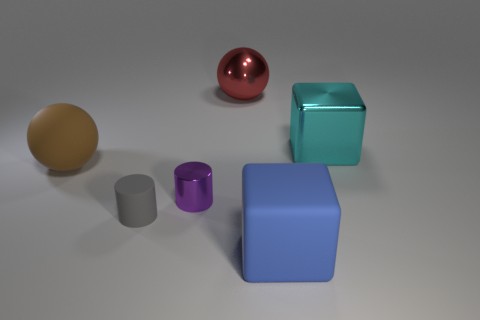Add 3 tiny gray things. How many objects exist? 9 Subtract all cylinders. How many objects are left? 4 Subtract 2 cubes. How many cubes are left? 0 Add 1 big gray matte blocks. How many big gray matte blocks exist? 1 Subtract 0 blue spheres. How many objects are left? 6 Subtract all green cubes. Subtract all green balls. How many cubes are left? 2 Subtract all brown blocks. How many yellow cylinders are left? 0 Subtract all small yellow metallic objects. Subtract all tiny metallic cylinders. How many objects are left? 5 Add 4 big cubes. How many big cubes are left? 6 